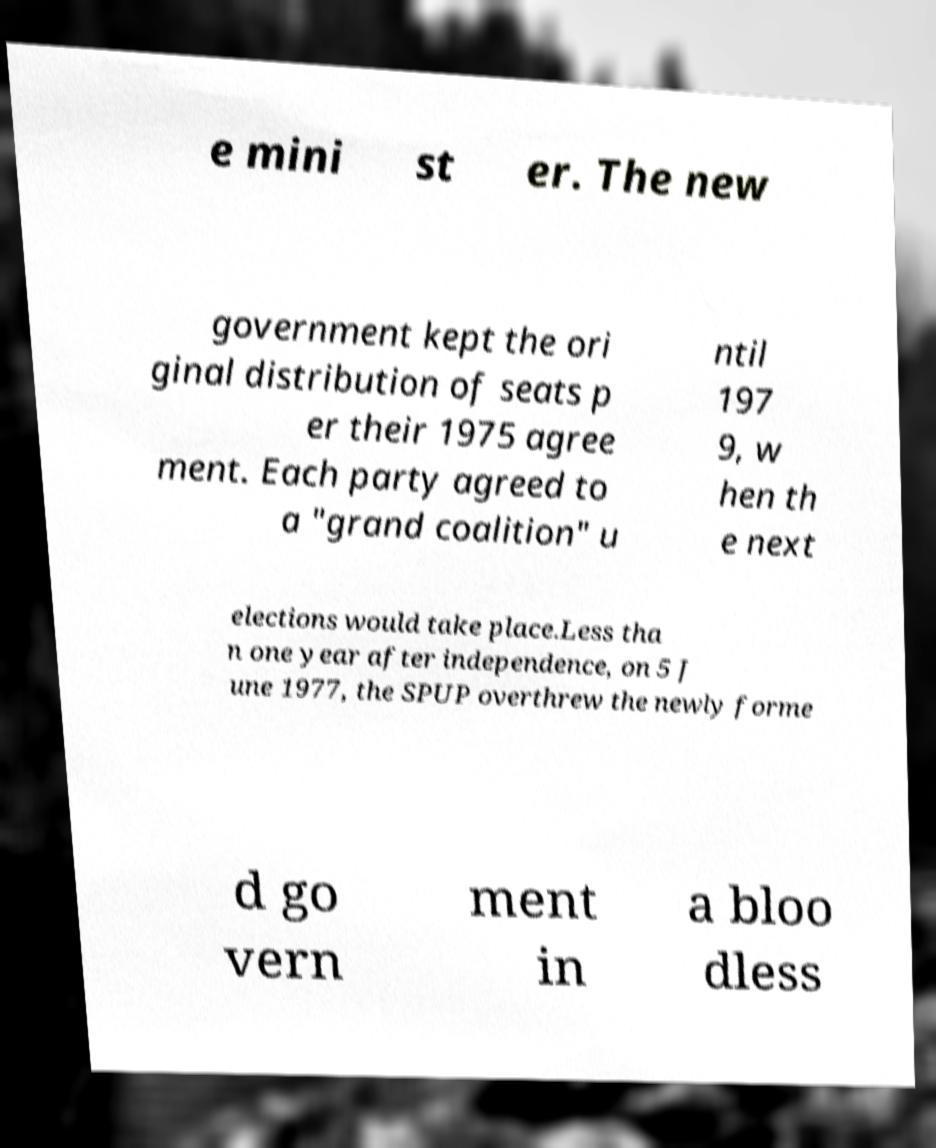What messages or text are displayed in this image? I need them in a readable, typed format. e mini st er. The new government kept the ori ginal distribution of seats p er their 1975 agree ment. Each party agreed to a "grand coalition" u ntil 197 9, w hen th e next elections would take place.Less tha n one year after independence, on 5 J une 1977, the SPUP overthrew the newly forme d go vern ment in a bloo dless 